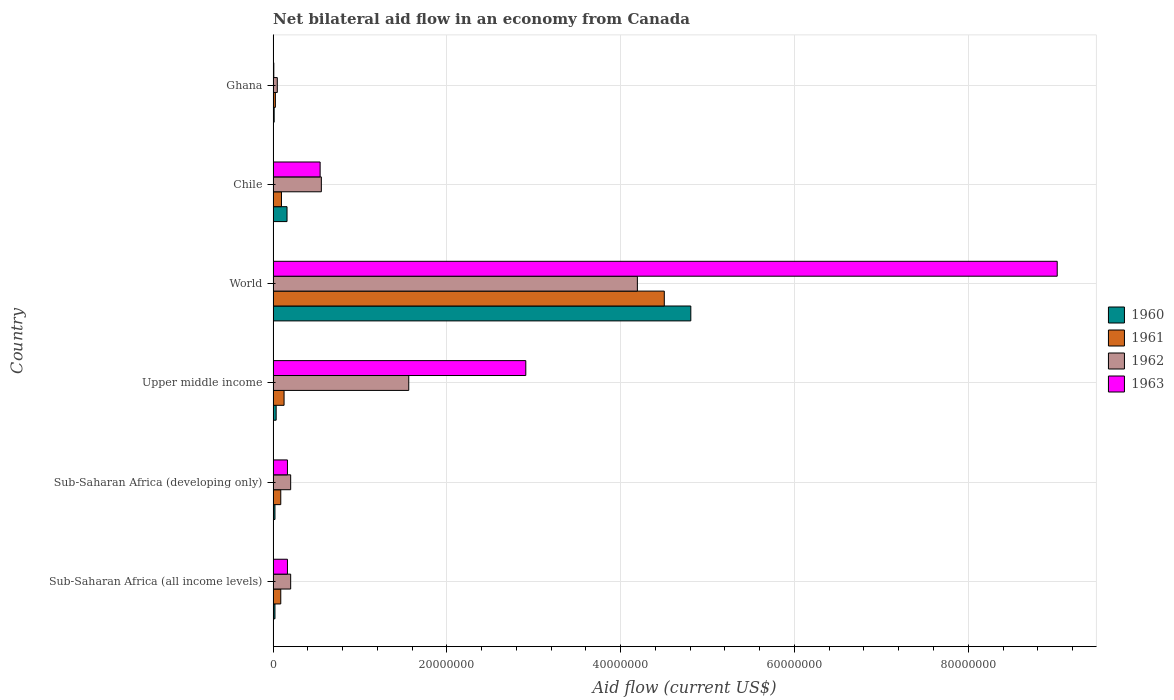How many groups of bars are there?
Your answer should be very brief. 6. Are the number of bars per tick equal to the number of legend labels?
Your response must be concise. Yes. Are the number of bars on each tick of the Y-axis equal?
Your answer should be compact. Yes. What is the label of the 1st group of bars from the top?
Make the answer very short. Ghana. What is the net bilateral aid flow in 1961 in Chile?
Keep it short and to the point. 9.60e+05. Across all countries, what is the maximum net bilateral aid flow in 1961?
Make the answer very short. 4.50e+07. In which country was the net bilateral aid flow in 1961 maximum?
Provide a short and direct response. World. What is the total net bilateral aid flow in 1961 in the graph?
Your answer should be compact. 4.93e+07. What is the difference between the net bilateral aid flow in 1963 in Sub-Saharan Africa (all income levels) and that in Upper middle income?
Ensure brevity in your answer.  -2.74e+07. What is the difference between the net bilateral aid flow in 1963 in Ghana and the net bilateral aid flow in 1961 in Upper middle income?
Provide a short and direct response. -1.18e+06. What is the average net bilateral aid flow in 1962 per country?
Make the answer very short. 1.13e+07. What is the difference between the net bilateral aid flow in 1963 and net bilateral aid flow in 1962 in World?
Provide a succinct answer. 4.83e+07. In how many countries, is the net bilateral aid flow in 1961 greater than 52000000 US$?
Provide a succinct answer. 0. What is the ratio of the net bilateral aid flow in 1962 in Chile to that in Upper middle income?
Offer a very short reply. 0.36. Is the net bilateral aid flow in 1960 in Sub-Saharan Africa (all income levels) less than that in Upper middle income?
Offer a very short reply. Yes. What is the difference between the highest and the second highest net bilateral aid flow in 1961?
Offer a terse response. 4.38e+07. What is the difference between the highest and the lowest net bilateral aid flow in 1963?
Your response must be concise. 9.02e+07. Is it the case that in every country, the sum of the net bilateral aid flow in 1962 and net bilateral aid flow in 1961 is greater than the sum of net bilateral aid flow in 1960 and net bilateral aid flow in 1963?
Offer a very short reply. No. What does the 4th bar from the top in Upper middle income represents?
Offer a very short reply. 1960. Is it the case that in every country, the sum of the net bilateral aid flow in 1960 and net bilateral aid flow in 1962 is greater than the net bilateral aid flow in 1963?
Offer a very short reply. No. How many bars are there?
Provide a short and direct response. 24. Are all the bars in the graph horizontal?
Provide a short and direct response. Yes. How many countries are there in the graph?
Give a very brief answer. 6. What is the difference between two consecutive major ticks on the X-axis?
Provide a short and direct response. 2.00e+07. Are the values on the major ticks of X-axis written in scientific E-notation?
Offer a terse response. No. Does the graph contain any zero values?
Make the answer very short. No. How are the legend labels stacked?
Provide a short and direct response. Vertical. What is the title of the graph?
Keep it short and to the point. Net bilateral aid flow in an economy from Canada. Does "1995" appear as one of the legend labels in the graph?
Provide a succinct answer. No. What is the label or title of the X-axis?
Provide a succinct answer. Aid flow (current US$). What is the label or title of the Y-axis?
Keep it short and to the point. Country. What is the Aid flow (current US$) in 1960 in Sub-Saharan Africa (all income levels)?
Provide a short and direct response. 2.10e+05. What is the Aid flow (current US$) in 1961 in Sub-Saharan Africa (all income levels)?
Provide a short and direct response. 8.80e+05. What is the Aid flow (current US$) of 1962 in Sub-Saharan Africa (all income levels)?
Offer a terse response. 2.02e+06. What is the Aid flow (current US$) of 1963 in Sub-Saharan Africa (all income levels)?
Make the answer very short. 1.65e+06. What is the Aid flow (current US$) in 1960 in Sub-Saharan Africa (developing only)?
Provide a succinct answer. 2.10e+05. What is the Aid flow (current US$) of 1961 in Sub-Saharan Africa (developing only)?
Your answer should be very brief. 8.80e+05. What is the Aid flow (current US$) in 1962 in Sub-Saharan Africa (developing only)?
Give a very brief answer. 2.02e+06. What is the Aid flow (current US$) of 1963 in Sub-Saharan Africa (developing only)?
Provide a short and direct response. 1.65e+06. What is the Aid flow (current US$) of 1961 in Upper middle income?
Your response must be concise. 1.26e+06. What is the Aid flow (current US$) of 1962 in Upper middle income?
Keep it short and to the point. 1.56e+07. What is the Aid flow (current US$) of 1963 in Upper middle income?
Your response must be concise. 2.91e+07. What is the Aid flow (current US$) in 1960 in World?
Offer a very short reply. 4.81e+07. What is the Aid flow (current US$) of 1961 in World?
Provide a short and direct response. 4.50e+07. What is the Aid flow (current US$) in 1962 in World?
Your response must be concise. 4.19e+07. What is the Aid flow (current US$) of 1963 in World?
Offer a very short reply. 9.02e+07. What is the Aid flow (current US$) in 1960 in Chile?
Offer a terse response. 1.60e+06. What is the Aid flow (current US$) of 1961 in Chile?
Keep it short and to the point. 9.60e+05. What is the Aid flow (current US$) of 1962 in Chile?
Provide a succinct answer. 5.55e+06. What is the Aid flow (current US$) in 1963 in Chile?
Make the answer very short. 5.41e+06. What is the Aid flow (current US$) of 1960 in Ghana?
Your answer should be compact. 1.20e+05. What is the Aid flow (current US$) of 1961 in Ghana?
Provide a succinct answer. 2.60e+05. What is the Aid flow (current US$) of 1962 in Ghana?
Provide a succinct answer. 4.80e+05. What is the Aid flow (current US$) in 1963 in Ghana?
Make the answer very short. 8.00e+04. Across all countries, what is the maximum Aid flow (current US$) in 1960?
Your answer should be very brief. 4.81e+07. Across all countries, what is the maximum Aid flow (current US$) in 1961?
Give a very brief answer. 4.50e+07. Across all countries, what is the maximum Aid flow (current US$) of 1962?
Keep it short and to the point. 4.19e+07. Across all countries, what is the maximum Aid flow (current US$) of 1963?
Provide a succinct answer. 9.02e+07. Across all countries, what is the minimum Aid flow (current US$) in 1960?
Keep it short and to the point. 1.20e+05. Across all countries, what is the minimum Aid flow (current US$) in 1961?
Your response must be concise. 2.60e+05. Across all countries, what is the minimum Aid flow (current US$) of 1963?
Provide a short and direct response. 8.00e+04. What is the total Aid flow (current US$) in 1960 in the graph?
Your answer should be very brief. 5.06e+07. What is the total Aid flow (current US$) of 1961 in the graph?
Your answer should be very brief. 4.93e+07. What is the total Aid flow (current US$) of 1962 in the graph?
Your answer should be compact. 6.76e+07. What is the total Aid flow (current US$) in 1963 in the graph?
Give a very brief answer. 1.28e+08. What is the difference between the Aid flow (current US$) of 1962 in Sub-Saharan Africa (all income levels) and that in Sub-Saharan Africa (developing only)?
Your answer should be very brief. 0. What is the difference between the Aid flow (current US$) in 1963 in Sub-Saharan Africa (all income levels) and that in Sub-Saharan Africa (developing only)?
Offer a terse response. 0. What is the difference between the Aid flow (current US$) of 1960 in Sub-Saharan Africa (all income levels) and that in Upper middle income?
Your response must be concise. -1.40e+05. What is the difference between the Aid flow (current US$) in 1961 in Sub-Saharan Africa (all income levels) and that in Upper middle income?
Give a very brief answer. -3.80e+05. What is the difference between the Aid flow (current US$) in 1962 in Sub-Saharan Africa (all income levels) and that in Upper middle income?
Offer a terse response. -1.36e+07. What is the difference between the Aid flow (current US$) in 1963 in Sub-Saharan Africa (all income levels) and that in Upper middle income?
Give a very brief answer. -2.74e+07. What is the difference between the Aid flow (current US$) in 1960 in Sub-Saharan Africa (all income levels) and that in World?
Give a very brief answer. -4.79e+07. What is the difference between the Aid flow (current US$) in 1961 in Sub-Saharan Africa (all income levels) and that in World?
Offer a very short reply. -4.41e+07. What is the difference between the Aid flow (current US$) in 1962 in Sub-Saharan Africa (all income levels) and that in World?
Make the answer very short. -3.99e+07. What is the difference between the Aid flow (current US$) in 1963 in Sub-Saharan Africa (all income levels) and that in World?
Offer a terse response. -8.86e+07. What is the difference between the Aid flow (current US$) of 1960 in Sub-Saharan Africa (all income levels) and that in Chile?
Keep it short and to the point. -1.39e+06. What is the difference between the Aid flow (current US$) of 1961 in Sub-Saharan Africa (all income levels) and that in Chile?
Offer a very short reply. -8.00e+04. What is the difference between the Aid flow (current US$) of 1962 in Sub-Saharan Africa (all income levels) and that in Chile?
Keep it short and to the point. -3.53e+06. What is the difference between the Aid flow (current US$) of 1963 in Sub-Saharan Africa (all income levels) and that in Chile?
Keep it short and to the point. -3.76e+06. What is the difference between the Aid flow (current US$) in 1960 in Sub-Saharan Africa (all income levels) and that in Ghana?
Your answer should be compact. 9.00e+04. What is the difference between the Aid flow (current US$) in 1961 in Sub-Saharan Africa (all income levels) and that in Ghana?
Offer a very short reply. 6.20e+05. What is the difference between the Aid flow (current US$) in 1962 in Sub-Saharan Africa (all income levels) and that in Ghana?
Your response must be concise. 1.54e+06. What is the difference between the Aid flow (current US$) in 1963 in Sub-Saharan Africa (all income levels) and that in Ghana?
Provide a short and direct response. 1.57e+06. What is the difference between the Aid flow (current US$) in 1960 in Sub-Saharan Africa (developing only) and that in Upper middle income?
Keep it short and to the point. -1.40e+05. What is the difference between the Aid flow (current US$) of 1961 in Sub-Saharan Africa (developing only) and that in Upper middle income?
Your answer should be compact. -3.80e+05. What is the difference between the Aid flow (current US$) of 1962 in Sub-Saharan Africa (developing only) and that in Upper middle income?
Your answer should be very brief. -1.36e+07. What is the difference between the Aid flow (current US$) of 1963 in Sub-Saharan Africa (developing only) and that in Upper middle income?
Give a very brief answer. -2.74e+07. What is the difference between the Aid flow (current US$) of 1960 in Sub-Saharan Africa (developing only) and that in World?
Provide a succinct answer. -4.79e+07. What is the difference between the Aid flow (current US$) in 1961 in Sub-Saharan Africa (developing only) and that in World?
Offer a terse response. -4.41e+07. What is the difference between the Aid flow (current US$) of 1962 in Sub-Saharan Africa (developing only) and that in World?
Provide a short and direct response. -3.99e+07. What is the difference between the Aid flow (current US$) in 1963 in Sub-Saharan Africa (developing only) and that in World?
Provide a short and direct response. -8.86e+07. What is the difference between the Aid flow (current US$) in 1960 in Sub-Saharan Africa (developing only) and that in Chile?
Keep it short and to the point. -1.39e+06. What is the difference between the Aid flow (current US$) of 1962 in Sub-Saharan Africa (developing only) and that in Chile?
Your answer should be compact. -3.53e+06. What is the difference between the Aid flow (current US$) of 1963 in Sub-Saharan Africa (developing only) and that in Chile?
Provide a short and direct response. -3.76e+06. What is the difference between the Aid flow (current US$) in 1961 in Sub-Saharan Africa (developing only) and that in Ghana?
Your answer should be compact. 6.20e+05. What is the difference between the Aid flow (current US$) of 1962 in Sub-Saharan Africa (developing only) and that in Ghana?
Provide a short and direct response. 1.54e+06. What is the difference between the Aid flow (current US$) of 1963 in Sub-Saharan Africa (developing only) and that in Ghana?
Provide a short and direct response. 1.57e+06. What is the difference between the Aid flow (current US$) in 1960 in Upper middle income and that in World?
Your response must be concise. -4.77e+07. What is the difference between the Aid flow (current US$) of 1961 in Upper middle income and that in World?
Your answer should be compact. -4.38e+07. What is the difference between the Aid flow (current US$) of 1962 in Upper middle income and that in World?
Keep it short and to the point. -2.63e+07. What is the difference between the Aid flow (current US$) of 1963 in Upper middle income and that in World?
Ensure brevity in your answer.  -6.12e+07. What is the difference between the Aid flow (current US$) in 1960 in Upper middle income and that in Chile?
Provide a succinct answer. -1.25e+06. What is the difference between the Aid flow (current US$) in 1962 in Upper middle income and that in Chile?
Ensure brevity in your answer.  1.01e+07. What is the difference between the Aid flow (current US$) in 1963 in Upper middle income and that in Chile?
Keep it short and to the point. 2.37e+07. What is the difference between the Aid flow (current US$) in 1960 in Upper middle income and that in Ghana?
Keep it short and to the point. 2.30e+05. What is the difference between the Aid flow (current US$) in 1962 in Upper middle income and that in Ghana?
Make the answer very short. 1.51e+07. What is the difference between the Aid flow (current US$) in 1963 in Upper middle income and that in Ghana?
Give a very brief answer. 2.90e+07. What is the difference between the Aid flow (current US$) of 1960 in World and that in Chile?
Your answer should be very brief. 4.65e+07. What is the difference between the Aid flow (current US$) in 1961 in World and that in Chile?
Keep it short and to the point. 4.41e+07. What is the difference between the Aid flow (current US$) in 1962 in World and that in Chile?
Make the answer very short. 3.64e+07. What is the difference between the Aid flow (current US$) of 1963 in World and that in Chile?
Keep it short and to the point. 8.48e+07. What is the difference between the Aid flow (current US$) of 1960 in World and that in Ghana?
Make the answer very short. 4.80e+07. What is the difference between the Aid flow (current US$) in 1961 in World and that in Ghana?
Make the answer very short. 4.48e+07. What is the difference between the Aid flow (current US$) of 1962 in World and that in Ghana?
Your answer should be very brief. 4.14e+07. What is the difference between the Aid flow (current US$) of 1963 in World and that in Ghana?
Ensure brevity in your answer.  9.02e+07. What is the difference between the Aid flow (current US$) of 1960 in Chile and that in Ghana?
Make the answer very short. 1.48e+06. What is the difference between the Aid flow (current US$) in 1962 in Chile and that in Ghana?
Ensure brevity in your answer.  5.07e+06. What is the difference between the Aid flow (current US$) of 1963 in Chile and that in Ghana?
Your answer should be very brief. 5.33e+06. What is the difference between the Aid flow (current US$) in 1960 in Sub-Saharan Africa (all income levels) and the Aid flow (current US$) in 1961 in Sub-Saharan Africa (developing only)?
Ensure brevity in your answer.  -6.70e+05. What is the difference between the Aid flow (current US$) of 1960 in Sub-Saharan Africa (all income levels) and the Aid flow (current US$) of 1962 in Sub-Saharan Africa (developing only)?
Offer a terse response. -1.81e+06. What is the difference between the Aid flow (current US$) of 1960 in Sub-Saharan Africa (all income levels) and the Aid flow (current US$) of 1963 in Sub-Saharan Africa (developing only)?
Give a very brief answer. -1.44e+06. What is the difference between the Aid flow (current US$) of 1961 in Sub-Saharan Africa (all income levels) and the Aid flow (current US$) of 1962 in Sub-Saharan Africa (developing only)?
Provide a succinct answer. -1.14e+06. What is the difference between the Aid flow (current US$) in 1961 in Sub-Saharan Africa (all income levels) and the Aid flow (current US$) in 1963 in Sub-Saharan Africa (developing only)?
Offer a terse response. -7.70e+05. What is the difference between the Aid flow (current US$) of 1960 in Sub-Saharan Africa (all income levels) and the Aid flow (current US$) of 1961 in Upper middle income?
Your answer should be very brief. -1.05e+06. What is the difference between the Aid flow (current US$) in 1960 in Sub-Saharan Africa (all income levels) and the Aid flow (current US$) in 1962 in Upper middle income?
Your response must be concise. -1.54e+07. What is the difference between the Aid flow (current US$) of 1960 in Sub-Saharan Africa (all income levels) and the Aid flow (current US$) of 1963 in Upper middle income?
Your answer should be very brief. -2.89e+07. What is the difference between the Aid flow (current US$) in 1961 in Sub-Saharan Africa (all income levels) and the Aid flow (current US$) in 1962 in Upper middle income?
Offer a very short reply. -1.47e+07. What is the difference between the Aid flow (current US$) of 1961 in Sub-Saharan Africa (all income levels) and the Aid flow (current US$) of 1963 in Upper middle income?
Give a very brief answer. -2.82e+07. What is the difference between the Aid flow (current US$) in 1962 in Sub-Saharan Africa (all income levels) and the Aid flow (current US$) in 1963 in Upper middle income?
Your response must be concise. -2.71e+07. What is the difference between the Aid flow (current US$) of 1960 in Sub-Saharan Africa (all income levels) and the Aid flow (current US$) of 1961 in World?
Ensure brevity in your answer.  -4.48e+07. What is the difference between the Aid flow (current US$) of 1960 in Sub-Saharan Africa (all income levels) and the Aid flow (current US$) of 1962 in World?
Ensure brevity in your answer.  -4.17e+07. What is the difference between the Aid flow (current US$) of 1960 in Sub-Saharan Africa (all income levels) and the Aid flow (current US$) of 1963 in World?
Give a very brief answer. -9.00e+07. What is the difference between the Aid flow (current US$) of 1961 in Sub-Saharan Africa (all income levels) and the Aid flow (current US$) of 1962 in World?
Offer a very short reply. -4.10e+07. What is the difference between the Aid flow (current US$) of 1961 in Sub-Saharan Africa (all income levels) and the Aid flow (current US$) of 1963 in World?
Ensure brevity in your answer.  -8.94e+07. What is the difference between the Aid flow (current US$) in 1962 in Sub-Saharan Africa (all income levels) and the Aid flow (current US$) in 1963 in World?
Give a very brief answer. -8.82e+07. What is the difference between the Aid flow (current US$) in 1960 in Sub-Saharan Africa (all income levels) and the Aid flow (current US$) in 1961 in Chile?
Ensure brevity in your answer.  -7.50e+05. What is the difference between the Aid flow (current US$) in 1960 in Sub-Saharan Africa (all income levels) and the Aid flow (current US$) in 1962 in Chile?
Keep it short and to the point. -5.34e+06. What is the difference between the Aid flow (current US$) in 1960 in Sub-Saharan Africa (all income levels) and the Aid flow (current US$) in 1963 in Chile?
Your answer should be very brief. -5.20e+06. What is the difference between the Aid flow (current US$) in 1961 in Sub-Saharan Africa (all income levels) and the Aid flow (current US$) in 1962 in Chile?
Your answer should be compact. -4.67e+06. What is the difference between the Aid flow (current US$) of 1961 in Sub-Saharan Africa (all income levels) and the Aid flow (current US$) of 1963 in Chile?
Your answer should be very brief. -4.53e+06. What is the difference between the Aid flow (current US$) of 1962 in Sub-Saharan Africa (all income levels) and the Aid flow (current US$) of 1963 in Chile?
Give a very brief answer. -3.39e+06. What is the difference between the Aid flow (current US$) of 1960 in Sub-Saharan Africa (all income levels) and the Aid flow (current US$) of 1961 in Ghana?
Offer a terse response. -5.00e+04. What is the difference between the Aid flow (current US$) in 1960 in Sub-Saharan Africa (all income levels) and the Aid flow (current US$) in 1962 in Ghana?
Make the answer very short. -2.70e+05. What is the difference between the Aid flow (current US$) of 1961 in Sub-Saharan Africa (all income levels) and the Aid flow (current US$) of 1962 in Ghana?
Make the answer very short. 4.00e+05. What is the difference between the Aid flow (current US$) of 1962 in Sub-Saharan Africa (all income levels) and the Aid flow (current US$) of 1963 in Ghana?
Your answer should be very brief. 1.94e+06. What is the difference between the Aid flow (current US$) of 1960 in Sub-Saharan Africa (developing only) and the Aid flow (current US$) of 1961 in Upper middle income?
Your response must be concise. -1.05e+06. What is the difference between the Aid flow (current US$) in 1960 in Sub-Saharan Africa (developing only) and the Aid flow (current US$) in 1962 in Upper middle income?
Your answer should be very brief. -1.54e+07. What is the difference between the Aid flow (current US$) in 1960 in Sub-Saharan Africa (developing only) and the Aid flow (current US$) in 1963 in Upper middle income?
Ensure brevity in your answer.  -2.89e+07. What is the difference between the Aid flow (current US$) of 1961 in Sub-Saharan Africa (developing only) and the Aid flow (current US$) of 1962 in Upper middle income?
Provide a short and direct response. -1.47e+07. What is the difference between the Aid flow (current US$) of 1961 in Sub-Saharan Africa (developing only) and the Aid flow (current US$) of 1963 in Upper middle income?
Offer a terse response. -2.82e+07. What is the difference between the Aid flow (current US$) of 1962 in Sub-Saharan Africa (developing only) and the Aid flow (current US$) of 1963 in Upper middle income?
Your response must be concise. -2.71e+07. What is the difference between the Aid flow (current US$) of 1960 in Sub-Saharan Africa (developing only) and the Aid flow (current US$) of 1961 in World?
Offer a very short reply. -4.48e+07. What is the difference between the Aid flow (current US$) of 1960 in Sub-Saharan Africa (developing only) and the Aid flow (current US$) of 1962 in World?
Give a very brief answer. -4.17e+07. What is the difference between the Aid flow (current US$) in 1960 in Sub-Saharan Africa (developing only) and the Aid flow (current US$) in 1963 in World?
Offer a terse response. -9.00e+07. What is the difference between the Aid flow (current US$) in 1961 in Sub-Saharan Africa (developing only) and the Aid flow (current US$) in 1962 in World?
Your response must be concise. -4.10e+07. What is the difference between the Aid flow (current US$) in 1961 in Sub-Saharan Africa (developing only) and the Aid flow (current US$) in 1963 in World?
Keep it short and to the point. -8.94e+07. What is the difference between the Aid flow (current US$) of 1962 in Sub-Saharan Africa (developing only) and the Aid flow (current US$) of 1963 in World?
Provide a short and direct response. -8.82e+07. What is the difference between the Aid flow (current US$) of 1960 in Sub-Saharan Africa (developing only) and the Aid flow (current US$) of 1961 in Chile?
Make the answer very short. -7.50e+05. What is the difference between the Aid flow (current US$) in 1960 in Sub-Saharan Africa (developing only) and the Aid flow (current US$) in 1962 in Chile?
Make the answer very short. -5.34e+06. What is the difference between the Aid flow (current US$) in 1960 in Sub-Saharan Africa (developing only) and the Aid flow (current US$) in 1963 in Chile?
Provide a succinct answer. -5.20e+06. What is the difference between the Aid flow (current US$) in 1961 in Sub-Saharan Africa (developing only) and the Aid flow (current US$) in 1962 in Chile?
Make the answer very short. -4.67e+06. What is the difference between the Aid flow (current US$) of 1961 in Sub-Saharan Africa (developing only) and the Aid flow (current US$) of 1963 in Chile?
Offer a terse response. -4.53e+06. What is the difference between the Aid flow (current US$) in 1962 in Sub-Saharan Africa (developing only) and the Aid flow (current US$) in 1963 in Chile?
Your answer should be very brief. -3.39e+06. What is the difference between the Aid flow (current US$) of 1960 in Sub-Saharan Africa (developing only) and the Aid flow (current US$) of 1962 in Ghana?
Offer a terse response. -2.70e+05. What is the difference between the Aid flow (current US$) of 1960 in Sub-Saharan Africa (developing only) and the Aid flow (current US$) of 1963 in Ghana?
Keep it short and to the point. 1.30e+05. What is the difference between the Aid flow (current US$) of 1961 in Sub-Saharan Africa (developing only) and the Aid flow (current US$) of 1963 in Ghana?
Give a very brief answer. 8.00e+05. What is the difference between the Aid flow (current US$) in 1962 in Sub-Saharan Africa (developing only) and the Aid flow (current US$) in 1963 in Ghana?
Offer a terse response. 1.94e+06. What is the difference between the Aid flow (current US$) in 1960 in Upper middle income and the Aid flow (current US$) in 1961 in World?
Keep it short and to the point. -4.47e+07. What is the difference between the Aid flow (current US$) of 1960 in Upper middle income and the Aid flow (current US$) of 1962 in World?
Give a very brief answer. -4.16e+07. What is the difference between the Aid flow (current US$) of 1960 in Upper middle income and the Aid flow (current US$) of 1963 in World?
Offer a terse response. -8.99e+07. What is the difference between the Aid flow (current US$) of 1961 in Upper middle income and the Aid flow (current US$) of 1962 in World?
Offer a terse response. -4.07e+07. What is the difference between the Aid flow (current US$) of 1961 in Upper middle income and the Aid flow (current US$) of 1963 in World?
Offer a terse response. -8.90e+07. What is the difference between the Aid flow (current US$) in 1962 in Upper middle income and the Aid flow (current US$) in 1963 in World?
Provide a succinct answer. -7.46e+07. What is the difference between the Aid flow (current US$) of 1960 in Upper middle income and the Aid flow (current US$) of 1961 in Chile?
Provide a short and direct response. -6.10e+05. What is the difference between the Aid flow (current US$) in 1960 in Upper middle income and the Aid flow (current US$) in 1962 in Chile?
Your response must be concise. -5.20e+06. What is the difference between the Aid flow (current US$) in 1960 in Upper middle income and the Aid flow (current US$) in 1963 in Chile?
Keep it short and to the point. -5.06e+06. What is the difference between the Aid flow (current US$) in 1961 in Upper middle income and the Aid flow (current US$) in 1962 in Chile?
Provide a short and direct response. -4.29e+06. What is the difference between the Aid flow (current US$) in 1961 in Upper middle income and the Aid flow (current US$) in 1963 in Chile?
Provide a short and direct response. -4.15e+06. What is the difference between the Aid flow (current US$) of 1962 in Upper middle income and the Aid flow (current US$) of 1963 in Chile?
Your answer should be compact. 1.02e+07. What is the difference between the Aid flow (current US$) in 1960 in Upper middle income and the Aid flow (current US$) in 1962 in Ghana?
Offer a terse response. -1.30e+05. What is the difference between the Aid flow (current US$) of 1960 in Upper middle income and the Aid flow (current US$) of 1963 in Ghana?
Provide a short and direct response. 2.70e+05. What is the difference between the Aid flow (current US$) in 1961 in Upper middle income and the Aid flow (current US$) in 1962 in Ghana?
Offer a very short reply. 7.80e+05. What is the difference between the Aid flow (current US$) in 1961 in Upper middle income and the Aid flow (current US$) in 1963 in Ghana?
Give a very brief answer. 1.18e+06. What is the difference between the Aid flow (current US$) in 1962 in Upper middle income and the Aid flow (current US$) in 1963 in Ghana?
Give a very brief answer. 1.55e+07. What is the difference between the Aid flow (current US$) of 1960 in World and the Aid flow (current US$) of 1961 in Chile?
Make the answer very short. 4.71e+07. What is the difference between the Aid flow (current US$) in 1960 in World and the Aid flow (current US$) in 1962 in Chile?
Ensure brevity in your answer.  4.25e+07. What is the difference between the Aid flow (current US$) in 1960 in World and the Aid flow (current US$) in 1963 in Chile?
Keep it short and to the point. 4.27e+07. What is the difference between the Aid flow (current US$) of 1961 in World and the Aid flow (current US$) of 1962 in Chile?
Offer a very short reply. 3.95e+07. What is the difference between the Aid flow (current US$) in 1961 in World and the Aid flow (current US$) in 1963 in Chile?
Provide a short and direct response. 3.96e+07. What is the difference between the Aid flow (current US$) in 1962 in World and the Aid flow (current US$) in 1963 in Chile?
Give a very brief answer. 3.65e+07. What is the difference between the Aid flow (current US$) in 1960 in World and the Aid flow (current US$) in 1961 in Ghana?
Offer a terse response. 4.78e+07. What is the difference between the Aid flow (current US$) in 1960 in World and the Aid flow (current US$) in 1962 in Ghana?
Provide a succinct answer. 4.76e+07. What is the difference between the Aid flow (current US$) in 1960 in World and the Aid flow (current US$) in 1963 in Ghana?
Your answer should be compact. 4.80e+07. What is the difference between the Aid flow (current US$) of 1961 in World and the Aid flow (current US$) of 1962 in Ghana?
Ensure brevity in your answer.  4.45e+07. What is the difference between the Aid flow (current US$) in 1961 in World and the Aid flow (current US$) in 1963 in Ghana?
Offer a terse response. 4.49e+07. What is the difference between the Aid flow (current US$) in 1962 in World and the Aid flow (current US$) in 1963 in Ghana?
Your answer should be very brief. 4.18e+07. What is the difference between the Aid flow (current US$) in 1960 in Chile and the Aid flow (current US$) in 1961 in Ghana?
Offer a very short reply. 1.34e+06. What is the difference between the Aid flow (current US$) of 1960 in Chile and the Aid flow (current US$) of 1962 in Ghana?
Give a very brief answer. 1.12e+06. What is the difference between the Aid flow (current US$) in 1960 in Chile and the Aid flow (current US$) in 1963 in Ghana?
Your answer should be compact. 1.52e+06. What is the difference between the Aid flow (current US$) of 1961 in Chile and the Aid flow (current US$) of 1962 in Ghana?
Your answer should be very brief. 4.80e+05. What is the difference between the Aid flow (current US$) of 1961 in Chile and the Aid flow (current US$) of 1963 in Ghana?
Your answer should be very brief. 8.80e+05. What is the difference between the Aid flow (current US$) in 1962 in Chile and the Aid flow (current US$) in 1963 in Ghana?
Provide a short and direct response. 5.47e+06. What is the average Aid flow (current US$) in 1960 per country?
Keep it short and to the point. 8.43e+06. What is the average Aid flow (current US$) in 1961 per country?
Provide a succinct answer. 8.21e+06. What is the average Aid flow (current US$) in 1962 per country?
Your response must be concise. 1.13e+07. What is the average Aid flow (current US$) of 1963 per country?
Offer a very short reply. 2.14e+07. What is the difference between the Aid flow (current US$) of 1960 and Aid flow (current US$) of 1961 in Sub-Saharan Africa (all income levels)?
Your answer should be compact. -6.70e+05. What is the difference between the Aid flow (current US$) in 1960 and Aid flow (current US$) in 1962 in Sub-Saharan Africa (all income levels)?
Give a very brief answer. -1.81e+06. What is the difference between the Aid flow (current US$) in 1960 and Aid flow (current US$) in 1963 in Sub-Saharan Africa (all income levels)?
Offer a very short reply. -1.44e+06. What is the difference between the Aid flow (current US$) in 1961 and Aid flow (current US$) in 1962 in Sub-Saharan Africa (all income levels)?
Your response must be concise. -1.14e+06. What is the difference between the Aid flow (current US$) in 1961 and Aid flow (current US$) in 1963 in Sub-Saharan Africa (all income levels)?
Offer a terse response. -7.70e+05. What is the difference between the Aid flow (current US$) in 1960 and Aid flow (current US$) in 1961 in Sub-Saharan Africa (developing only)?
Keep it short and to the point. -6.70e+05. What is the difference between the Aid flow (current US$) in 1960 and Aid flow (current US$) in 1962 in Sub-Saharan Africa (developing only)?
Keep it short and to the point. -1.81e+06. What is the difference between the Aid flow (current US$) of 1960 and Aid flow (current US$) of 1963 in Sub-Saharan Africa (developing only)?
Offer a terse response. -1.44e+06. What is the difference between the Aid flow (current US$) in 1961 and Aid flow (current US$) in 1962 in Sub-Saharan Africa (developing only)?
Keep it short and to the point. -1.14e+06. What is the difference between the Aid flow (current US$) in 1961 and Aid flow (current US$) in 1963 in Sub-Saharan Africa (developing only)?
Give a very brief answer. -7.70e+05. What is the difference between the Aid flow (current US$) of 1962 and Aid flow (current US$) of 1963 in Sub-Saharan Africa (developing only)?
Keep it short and to the point. 3.70e+05. What is the difference between the Aid flow (current US$) of 1960 and Aid flow (current US$) of 1961 in Upper middle income?
Make the answer very short. -9.10e+05. What is the difference between the Aid flow (current US$) of 1960 and Aid flow (current US$) of 1962 in Upper middle income?
Your answer should be very brief. -1.53e+07. What is the difference between the Aid flow (current US$) in 1960 and Aid flow (current US$) in 1963 in Upper middle income?
Make the answer very short. -2.87e+07. What is the difference between the Aid flow (current US$) of 1961 and Aid flow (current US$) of 1962 in Upper middle income?
Your answer should be compact. -1.44e+07. What is the difference between the Aid flow (current US$) of 1961 and Aid flow (current US$) of 1963 in Upper middle income?
Make the answer very short. -2.78e+07. What is the difference between the Aid flow (current US$) of 1962 and Aid flow (current US$) of 1963 in Upper middle income?
Your response must be concise. -1.35e+07. What is the difference between the Aid flow (current US$) in 1960 and Aid flow (current US$) in 1961 in World?
Offer a terse response. 3.05e+06. What is the difference between the Aid flow (current US$) in 1960 and Aid flow (current US$) in 1962 in World?
Give a very brief answer. 6.15e+06. What is the difference between the Aid flow (current US$) of 1960 and Aid flow (current US$) of 1963 in World?
Provide a succinct answer. -4.22e+07. What is the difference between the Aid flow (current US$) of 1961 and Aid flow (current US$) of 1962 in World?
Offer a terse response. 3.10e+06. What is the difference between the Aid flow (current US$) in 1961 and Aid flow (current US$) in 1963 in World?
Offer a very short reply. -4.52e+07. What is the difference between the Aid flow (current US$) of 1962 and Aid flow (current US$) of 1963 in World?
Keep it short and to the point. -4.83e+07. What is the difference between the Aid flow (current US$) in 1960 and Aid flow (current US$) in 1961 in Chile?
Make the answer very short. 6.40e+05. What is the difference between the Aid flow (current US$) in 1960 and Aid flow (current US$) in 1962 in Chile?
Give a very brief answer. -3.95e+06. What is the difference between the Aid flow (current US$) in 1960 and Aid flow (current US$) in 1963 in Chile?
Keep it short and to the point. -3.81e+06. What is the difference between the Aid flow (current US$) of 1961 and Aid flow (current US$) of 1962 in Chile?
Offer a terse response. -4.59e+06. What is the difference between the Aid flow (current US$) of 1961 and Aid flow (current US$) of 1963 in Chile?
Offer a terse response. -4.45e+06. What is the difference between the Aid flow (current US$) in 1960 and Aid flow (current US$) in 1962 in Ghana?
Offer a very short reply. -3.60e+05. What is the difference between the Aid flow (current US$) in 1960 and Aid flow (current US$) in 1963 in Ghana?
Give a very brief answer. 4.00e+04. What is the difference between the Aid flow (current US$) of 1961 and Aid flow (current US$) of 1962 in Ghana?
Your response must be concise. -2.20e+05. What is the difference between the Aid flow (current US$) in 1962 and Aid flow (current US$) in 1963 in Ghana?
Offer a terse response. 4.00e+05. What is the ratio of the Aid flow (current US$) in 1962 in Sub-Saharan Africa (all income levels) to that in Sub-Saharan Africa (developing only)?
Make the answer very short. 1. What is the ratio of the Aid flow (current US$) in 1960 in Sub-Saharan Africa (all income levels) to that in Upper middle income?
Give a very brief answer. 0.6. What is the ratio of the Aid flow (current US$) in 1961 in Sub-Saharan Africa (all income levels) to that in Upper middle income?
Make the answer very short. 0.7. What is the ratio of the Aid flow (current US$) of 1962 in Sub-Saharan Africa (all income levels) to that in Upper middle income?
Provide a succinct answer. 0.13. What is the ratio of the Aid flow (current US$) in 1963 in Sub-Saharan Africa (all income levels) to that in Upper middle income?
Your answer should be very brief. 0.06. What is the ratio of the Aid flow (current US$) of 1960 in Sub-Saharan Africa (all income levels) to that in World?
Make the answer very short. 0. What is the ratio of the Aid flow (current US$) in 1961 in Sub-Saharan Africa (all income levels) to that in World?
Make the answer very short. 0.02. What is the ratio of the Aid flow (current US$) in 1962 in Sub-Saharan Africa (all income levels) to that in World?
Ensure brevity in your answer.  0.05. What is the ratio of the Aid flow (current US$) in 1963 in Sub-Saharan Africa (all income levels) to that in World?
Offer a very short reply. 0.02. What is the ratio of the Aid flow (current US$) in 1960 in Sub-Saharan Africa (all income levels) to that in Chile?
Offer a terse response. 0.13. What is the ratio of the Aid flow (current US$) of 1962 in Sub-Saharan Africa (all income levels) to that in Chile?
Your response must be concise. 0.36. What is the ratio of the Aid flow (current US$) in 1963 in Sub-Saharan Africa (all income levels) to that in Chile?
Your answer should be compact. 0.3. What is the ratio of the Aid flow (current US$) of 1961 in Sub-Saharan Africa (all income levels) to that in Ghana?
Offer a terse response. 3.38. What is the ratio of the Aid flow (current US$) of 1962 in Sub-Saharan Africa (all income levels) to that in Ghana?
Ensure brevity in your answer.  4.21. What is the ratio of the Aid flow (current US$) of 1963 in Sub-Saharan Africa (all income levels) to that in Ghana?
Your answer should be very brief. 20.62. What is the ratio of the Aid flow (current US$) in 1960 in Sub-Saharan Africa (developing only) to that in Upper middle income?
Offer a terse response. 0.6. What is the ratio of the Aid flow (current US$) of 1961 in Sub-Saharan Africa (developing only) to that in Upper middle income?
Offer a terse response. 0.7. What is the ratio of the Aid flow (current US$) of 1962 in Sub-Saharan Africa (developing only) to that in Upper middle income?
Offer a terse response. 0.13. What is the ratio of the Aid flow (current US$) of 1963 in Sub-Saharan Africa (developing only) to that in Upper middle income?
Give a very brief answer. 0.06. What is the ratio of the Aid flow (current US$) in 1960 in Sub-Saharan Africa (developing only) to that in World?
Offer a terse response. 0. What is the ratio of the Aid flow (current US$) of 1961 in Sub-Saharan Africa (developing only) to that in World?
Your response must be concise. 0.02. What is the ratio of the Aid flow (current US$) in 1962 in Sub-Saharan Africa (developing only) to that in World?
Make the answer very short. 0.05. What is the ratio of the Aid flow (current US$) in 1963 in Sub-Saharan Africa (developing only) to that in World?
Make the answer very short. 0.02. What is the ratio of the Aid flow (current US$) of 1960 in Sub-Saharan Africa (developing only) to that in Chile?
Provide a succinct answer. 0.13. What is the ratio of the Aid flow (current US$) in 1961 in Sub-Saharan Africa (developing only) to that in Chile?
Provide a succinct answer. 0.92. What is the ratio of the Aid flow (current US$) in 1962 in Sub-Saharan Africa (developing only) to that in Chile?
Your answer should be compact. 0.36. What is the ratio of the Aid flow (current US$) in 1963 in Sub-Saharan Africa (developing only) to that in Chile?
Ensure brevity in your answer.  0.3. What is the ratio of the Aid flow (current US$) in 1961 in Sub-Saharan Africa (developing only) to that in Ghana?
Provide a succinct answer. 3.38. What is the ratio of the Aid flow (current US$) in 1962 in Sub-Saharan Africa (developing only) to that in Ghana?
Provide a succinct answer. 4.21. What is the ratio of the Aid flow (current US$) of 1963 in Sub-Saharan Africa (developing only) to that in Ghana?
Ensure brevity in your answer.  20.62. What is the ratio of the Aid flow (current US$) in 1960 in Upper middle income to that in World?
Offer a terse response. 0.01. What is the ratio of the Aid flow (current US$) in 1961 in Upper middle income to that in World?
Provide a short and direct response. 0.03. What is the ratio of the Aid flow (current US$) in 1962 in Upper middle income to that in World?
Provide a short and direct response. 0.37. What is the ratio of the Aid flow (current US$) of 1963 in Upper middle income to that in World?
Provide a short and direct response. 0.32. What is the ratio of the Aid flow (current US$) of 1960 in Upper middle income to that in Chile?
Keep it short and to the point. 0.22. What is the ratio of the Aid flow (current US$) in 1961 in Upper middle income to that in Chile?
Your answer should be very brief. 1.31. What is the ratio of the Aid flow (current US$) of 1962 in Upper middle income to that in Chile?
Keep it short and to the point. 2.81. What is the ratio of the Aid flow (current US$) of 1963 in Upper middle income to that in Chile?
Make the answer very short. 5.38. What is the ratio of the Aid flow (current US$) of 1960 in Upper middle income to that in Ghana?
Give a very brief answer. 2.92. What is the ratio of the Aid flow (current US$) in 1961 in Upper middle income to that in Ghana?
Your response must be concise. 4.85. What is the ratio of the Aid flow (current US$) in 1962 in Upper middle income to that in Ghana?
Your answer should be very brief. 32.52. What is the ratio of the Aid flow (current US$) in 1963 in Upper middle income to that in Ghana?
Keep it short and to the point. 363.5. What is the ratio of the Aid flow (current US$) of 1960 in World to that in Chile?
Your answer should be very brief. 30.04. What is the ratio of the Aid flow (current US$) in 1961 in World to that in Chile?
Make the answer very short. 46.9. What is the ratio of the Aid flow (current US$) of 1962 in World to that in Chile?
Keep it short and to the point. 7.55. What is the ratio of the Aid flow (current US$) of 1963 in World to that in Chile?
Keep it short and to the point. 16.68. What is the ratio of the Aid flow (current US$) of 1960 in World to that in Ghana?
Give a very brief answer. 400.58. What is the ratio of the Aid flow (current US$) of 1961 in World to that in Ghana?
Provide a succinct answer. 173.15. What is the ratio of the Aid flow (current US$) in 1962 in World to that in Ghana?
Keep it short and to the point. 87.33. What is the ratio of the Aid flow (current US$) of 1963 in World to that in Ghana?
Your answer should be compact. 1128. What is the ratio of the Aid flow (current US$) of 1960 in Chile to that in Ghana?
Keep it short and to the point. 13.33. What is the ratio of the Aid flow (current US$) of 1961 in Chile to that in Ghana?
Give a very brief answer. 3.69. What is the ratio of the Aid flow (current US$) in 1962 in Chile to that in Ghana?
Keep it short and to the point. 11.56. What is the ratio of the Aid flow (current US$) of 1963 in Chile to that in Ghana?
Your answer should be compact. 67.62. What is the difference between the highest and the second highest Aid flow (current US$) of 1960?
Keep it short and to the point. 4.65e+07. What is the difference between the highest and the second highest Aid flow (current US$) in 1961?
Make the answer very short. 4.38e+07. What is the difference between the highest and the second highest Aid flow (current US$) in 1962?
Your answer should be very brief. 2.63e+07. What is the difference between the highest and the second highest Aid flow (current US$) of 1963?
Give a very brief answer. 6.12e+07. What is the difference between the highest and the lowest Aid flow (current US$) in 1960?
Your answer should be very brief. 4.80e+07. What is the difference between the highest and the lowest Aid flow (current US$) in 1961?
Your answer should be compact. 4.48e+07. What is the difference between the highest and the lowest Aid flow (current US$) in 1962?
Provide a succinct answer. 4.14e+07. What is the difference between the highest and the lowest Aid flow (current US$) of 1963?
Ensure brevity in your answer.  9.02e+07. 